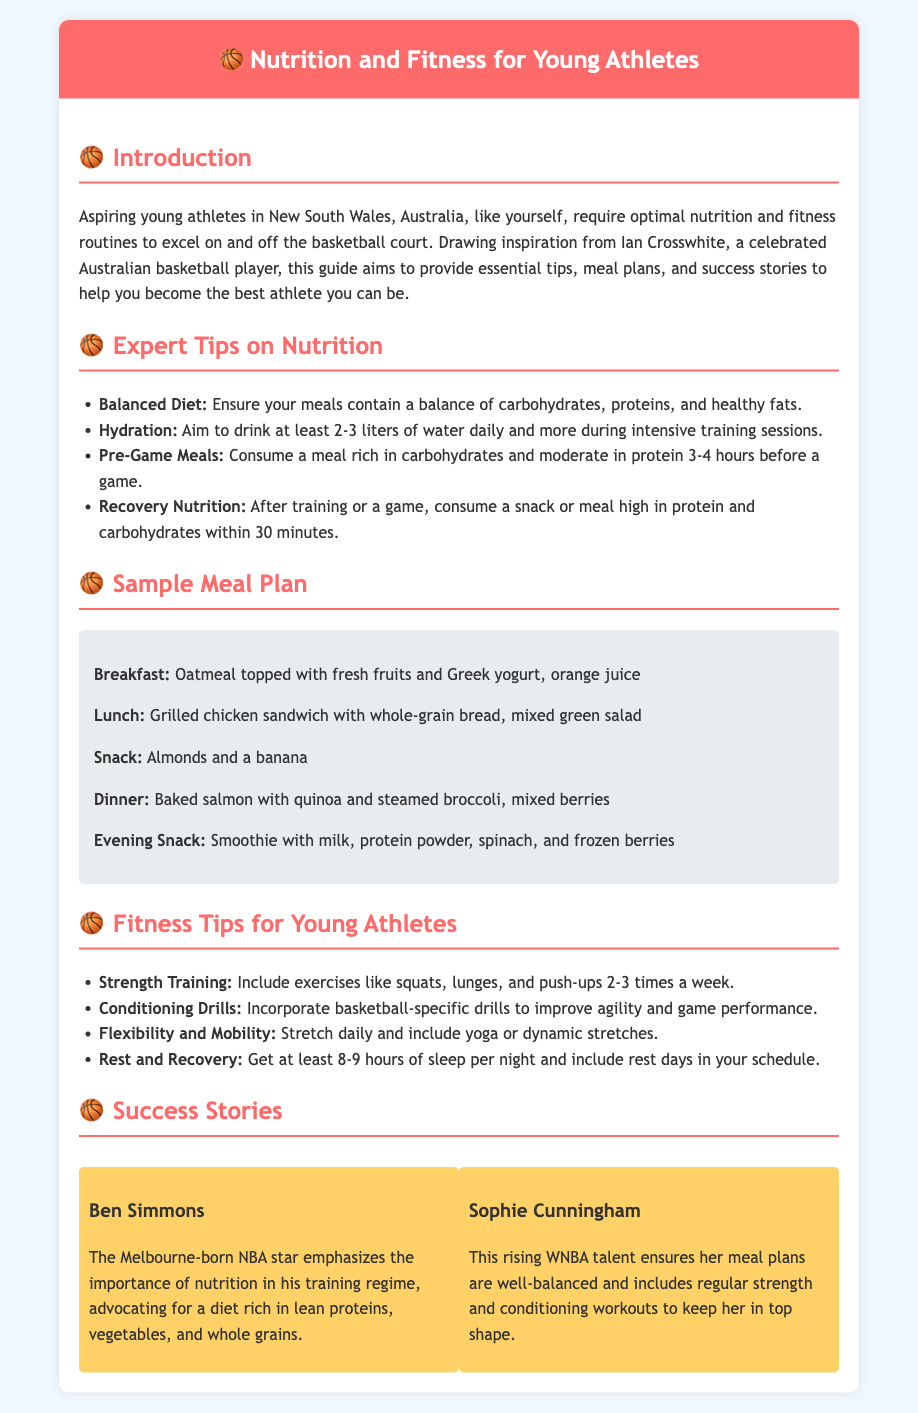What is the significance of a balanced diet? The document mentions that aspiring young athletes should ensure their meals contain a balance of carbohydrates, proteins, and healthy fats.
Answer: Ensure meals contain a balance of carbohydrates, proteins, and healthy fats How much water should young athletes drink daily? It states that young athletes should aim to drink at least 2-3 liters of water daily and more during intensive training sessions.
Answer: 2-3 liters What is a recommended pre-game meal? The guide suggests consuming a meal rich in carbohydrates and moderate in protein 3-4 hours before a game.
Answer: Rich in carbohydrates and moderate in protein What does the sample breakfast include? The breakfast listed in the meal plan is oatmeal topped with fresh fruits and Greek yogurt, along with orange juice.
Answer: Oatmeal topped with fresh fruits and Greek yogurt, orange juice Who is a success story mentioned in the document? The document highlights Ben Simmons as a success story, emphasizing his views on nutrition in training.
Answer: Ben Simmons How many hours of sleep should young athletes get? It specifies that young athletes should get at least 8-9 hours of sleep per night.
Answer: 8-9 hours What type of strength training is recommended? The document recommends including exercises like squats, lunges, and push-ups 2-3 times a week.
Answer: Squats, lunges, and push-ups Which young athlete includes strength and conditioning in her training? The success story of Sophie Cunningham mentions her regular strength and conditioning workouts.
Answer: Sophie Cunningham What aspect of fitness involves stretching and yoga? The document includes flexibility and mobility as an important aspect of fitness, mentioning daily stretching and yoga.
Answer: Flexibility and mobility 